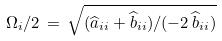Convert formula to latex. <formula><loc_0><loc_0><loc_500><loc_500>\Omega _ { i } / 2 \, = \, \sqrt { ( \widehat { a } _ { i i } + \widehat { b } _ { i i } ) / ( - 2 \, \widehat { b } _ { i i } ) }</formula> 